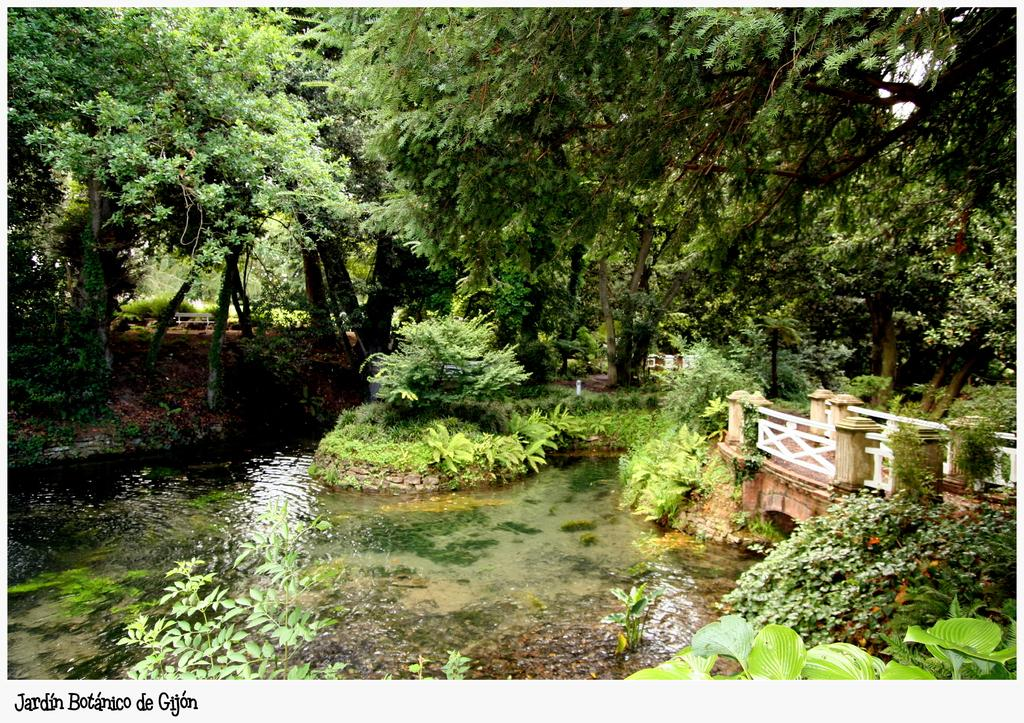What is located in the middle of the image? There is water in the middle of the image. What types of vegetation can be seen in the image? There are plants and trees in the image. What architectural feature is present on the right side of the image? There is a small bridge on the right side of the image. What type of underwear is hanging on the trees in the image? There is no underwear present in the image; it features water, plants, trees, and a small bridge. 